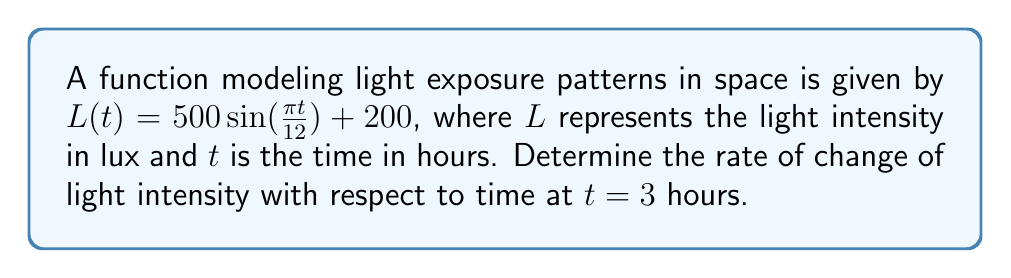Could you help me with this problem? To find the rate of change of light intensity with respect to time, we need to determine the derivative of the function $L(t)$ and then evaluate it at $t = 3$.

Step 1: Find the derivative of $L(t)$
$$L(t) = 500 \sin(\frac{\pi t}{12}) + 200$$
Using the chain rule, we get:
$$L'(t) = 500 \cdot \cos(\frac{\pi t}{12}) \cdot \frac{\pi}{12}$$

Step 2: Simplify the derivative
$$L'(t) = \frac{500\pi}{12} \cos(\frac{\pi t}{12})$$

Step 3: Evaluate the derivative at $t = 3$
$$L'(3) = \frac{500\pi}{12} \cos(\frac{\pi \cdot 3}{12})$$
$$L'(3) = \frac{500\pi}{12} \cos(\frac{\pi}{4})$$

Step 4: Calculate the final value
$$L'(3) = \frac{500\pi}{12} \cdot \frac{\sqrt{2}}{2}$$
$$L'(3) \approx 45.96 \text{ lux/hour}$$
Answer: $\frac{500\pi\sqrt{2}}{24} \text{ lux/hour}$ or approximately $45.96 \text{ lux/hour}$ 